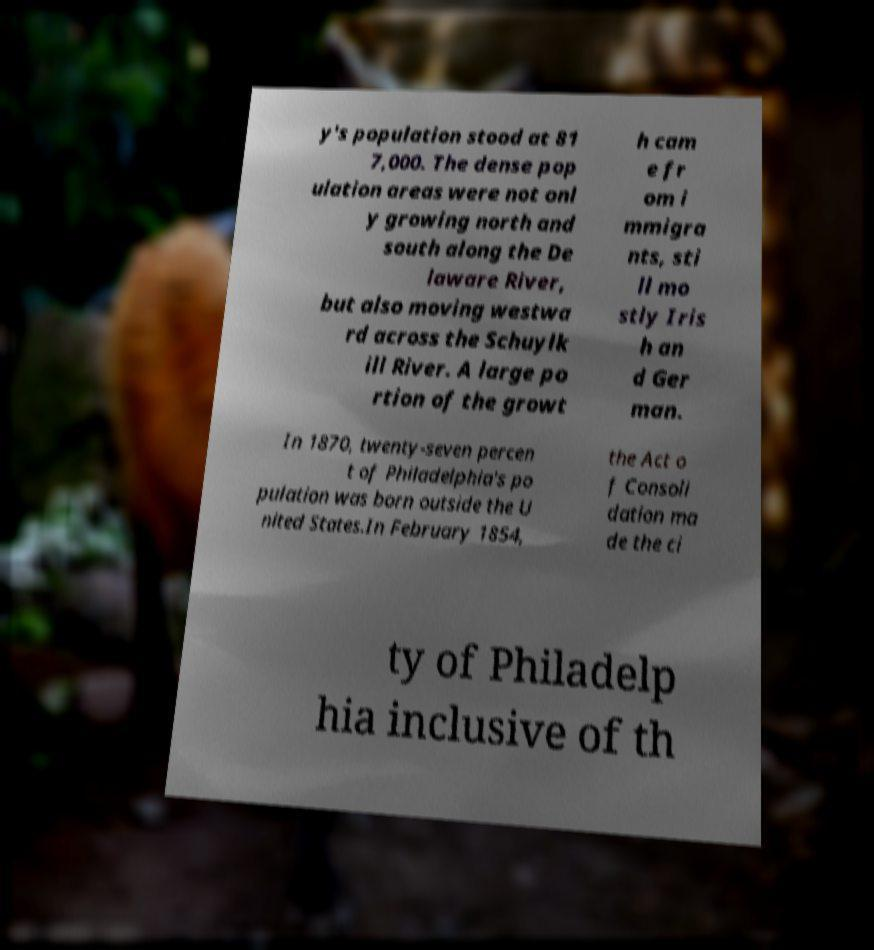Could you extract and type out the text from this image? y's population stood at 81 7,000. The dense pop ulation areas were not onl y growing north and south along the De laware River, but also moving westwa rd across the Schuylk ill River. A large po rtion of the growt h cam e fr om i mmigra nts, sti ll mo stly Iris h an d Ger man. In 1870, twenty-seven percen t of Philadelphia's po pulation was born outside the U nited States.In February 1854, the Act o f Consoli dation ma de the ci ty of Philadelp hia inclusive of th 